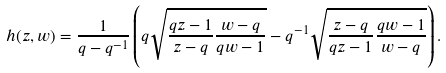<formula> <loc_0><loc_0><loc_500><loc_500>h ( z , w ) = \frac { 1 } { q - q ^ { - 1 } } \left ( q \sqrt { \frac { q z - 1 } { z - q } \frac { w - q } { q w - 1 } } - q ^ { - 1 } \sqrt { \frac { z - q } { q z - 1 } \frac { q w - 1 } { w - q } } \right ) .</formula> 